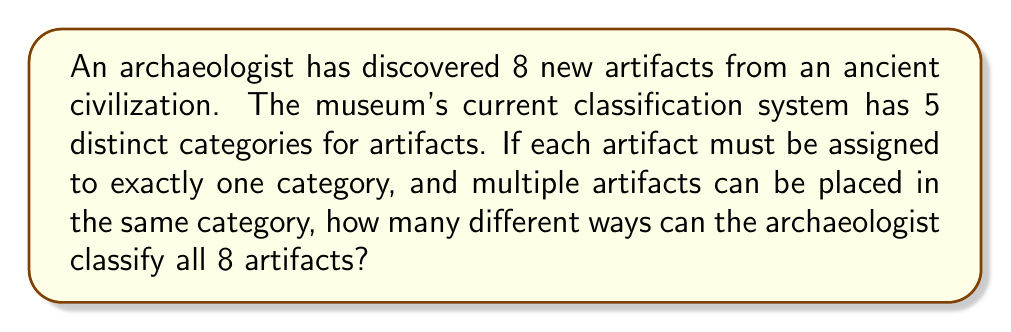What is the answer to this math problem? Let's approach this step-by-step:

1) This problem is an example of distributing distinguishable objects (the 8 artifacts) into distinguishable boxes (the 5 categories).

2) Each artifact has 5 choices (categories) it can be placed in, independent of where the other artifacts are placed.

3) This scenario can be modeled using the multiplication principle.

4) For the first artifact, we have 5 choices.
   For the second artifact, we again have 5 choices.
   This continues for all 8 artifacts.

5) Therefore, the total number of ways to classify the artifacts is:

   $$5 \times 5 \times 5 \times 5 \times 5 \times 5 \times 5 \times 5 = 5^8$$

6) We can calculate this:

   $$5^8 = 390625$$

Thus, there are 390,625 different ways to classify the 8 artifacts into the 5 categories.
Answer: $5^8 = 390625$ 